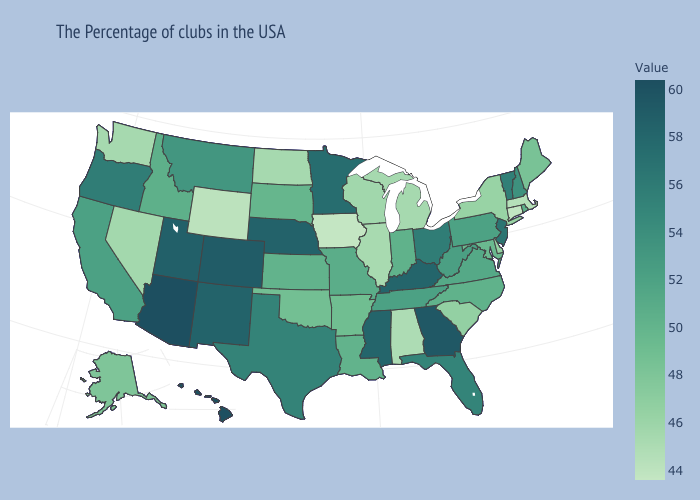Which states hav the highest value in the South?
Be succinct. Georgia. Does Massachusetts have the lowest value in the USA?
Be succinct. No. Does Ohio have a higher value than Kansas?
Be succinct. Yes. Among the states that border Idaho , which have the highest value?
Write a very short answer. Utah. Among the states that border Kansas , does Colorado have the highest value?
Short answer required. Yes. Does New Jersey have the highest value in the Northeast?
Short answer required. Yes. Does Mississippi have the highest value in the USA?
Quick response, please. No. Among the states that border Kentucky , which have the highest value?
Write a very short answer. Ohio. 